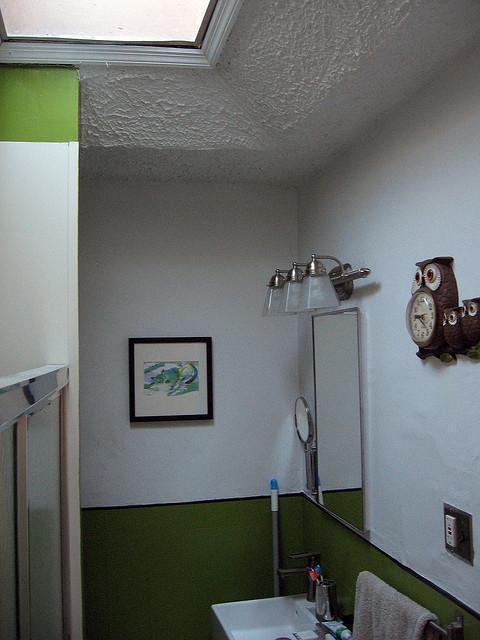How many toothbrushes are in this photo?
Give a very brief answer. 2. How many pictures are on the wall?
Give a very brief answer. 1. How many cats are there?
Give a very brief answer. 0. 